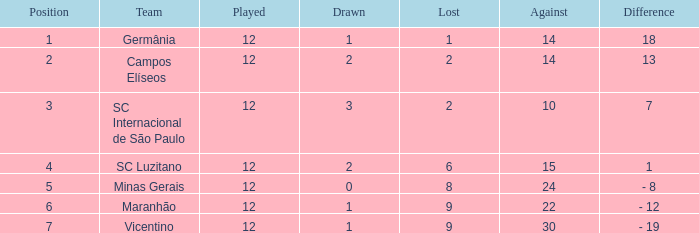In what case is there a difference of over 10 points and under 2 draws? 18.0. 